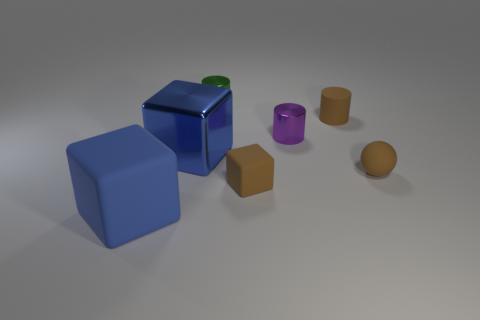Subtract all tiny brown cylinders. How many cylinders are left? 2 Subtract all blue spheres. How many blue blocks are left? 2 Add 1 large shiny objects. How many objects exist? 8 Subtract all red blocks. Subtract all purple balls. How many blocks are left? 3 Subtract 0 gray blocks. How many objects are left? 7 Subtract all balls. How many objects are left? 6 Subtract all matte things. Subtract all big blue rubber blocks. How many objects are left? 2 Add 6 large blue things. How many large blue things are left? 8 Add 2 green matte objects. How many green matte objects exist? 2 